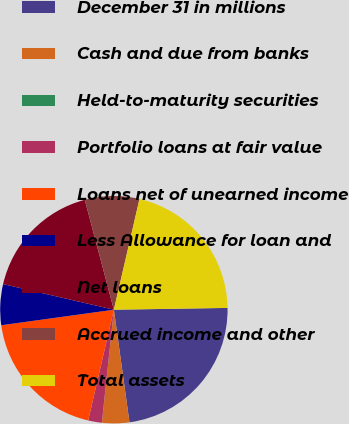<chart> <loc_0><loc_0><loc_500><loc_500><pie_chart><fcel>December 31 in millions<fcel>Cash and due from banks<fcel>Held-to-maturity securities<fcel>Portfolio loans at fair value<fcel>Loans net of unearned income<fcel>Less Allowance for loan and<fcel>Net loans<fcel>Accrued income and other<fcel>Total assets<nl><fcel>23.06%<fcel>3.87%<fcel>0.01%<fcel>1.94%<fcel>19.19%<fcel>5.8%<fcel>17.26%<fcel>7.74%<fcel>21.13%<nl></chart> 